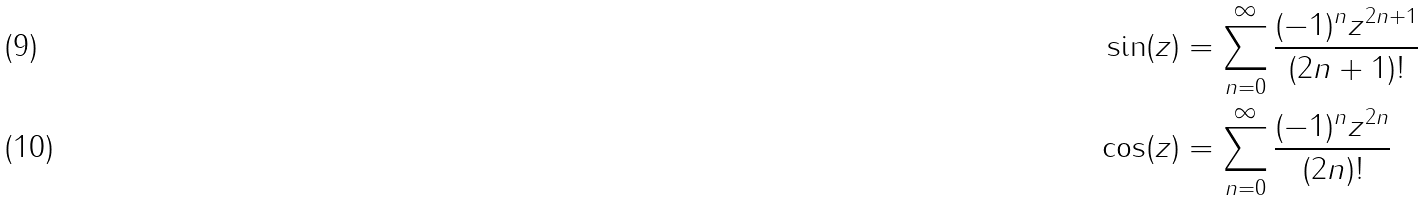<formula> <loc_0><loc_0><loc_500><loc_500>\sin ( z ) & = \sum _ { n = 0 } ^ { \infty } \frac { ( - 1 ) ^ { n } z ^ { 2 n + 1 } } { ( 2 n + 1 ) ! } \\ \cos ( z ) & = \sum _ { n = 0 } ^ { \infty } \frac { ( - 1 ) ^ { n } z ^ { 2 n } } { ( 2 n ) ! }</formula> 